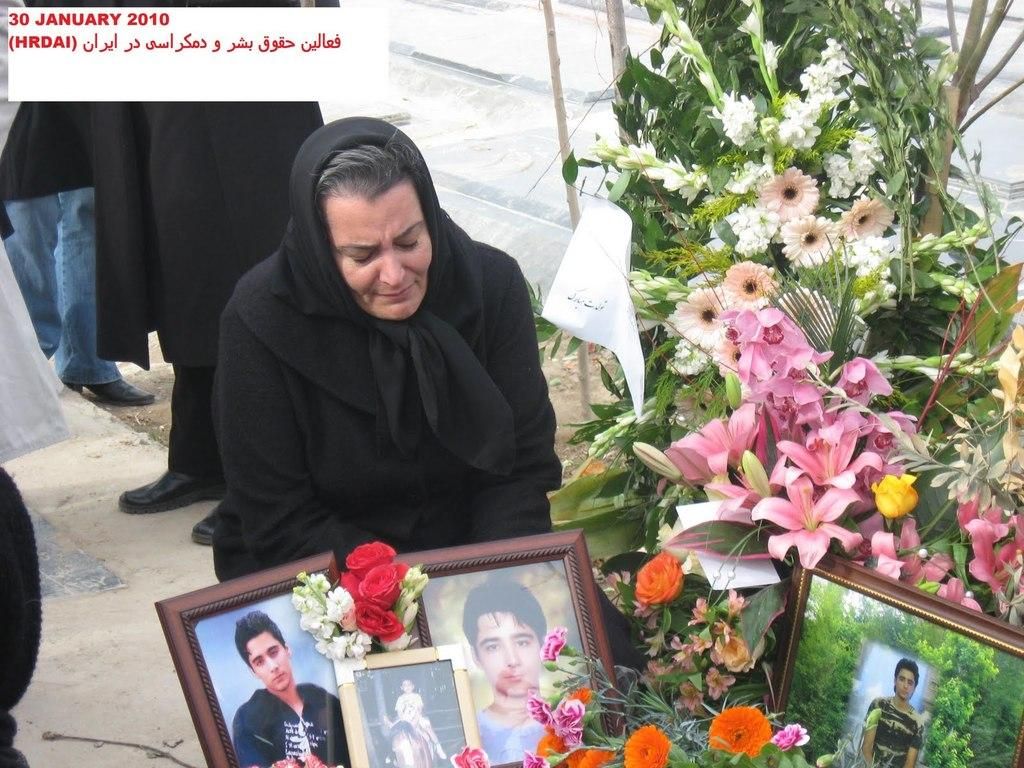How many people are visible in the image? There are persons standing in the image. What is the woman in the image doing? There is a woman sitting on the ground in the image. What type of object can be seen in the image that is typically used for decoration? There is a flower bouquet in the image. What type of object is present in the image that is often used for displaying photographs? There are photo frames in the image. What type of air can be seen in the image? There is no air visible in the image; it is a two-dimensional representation. 